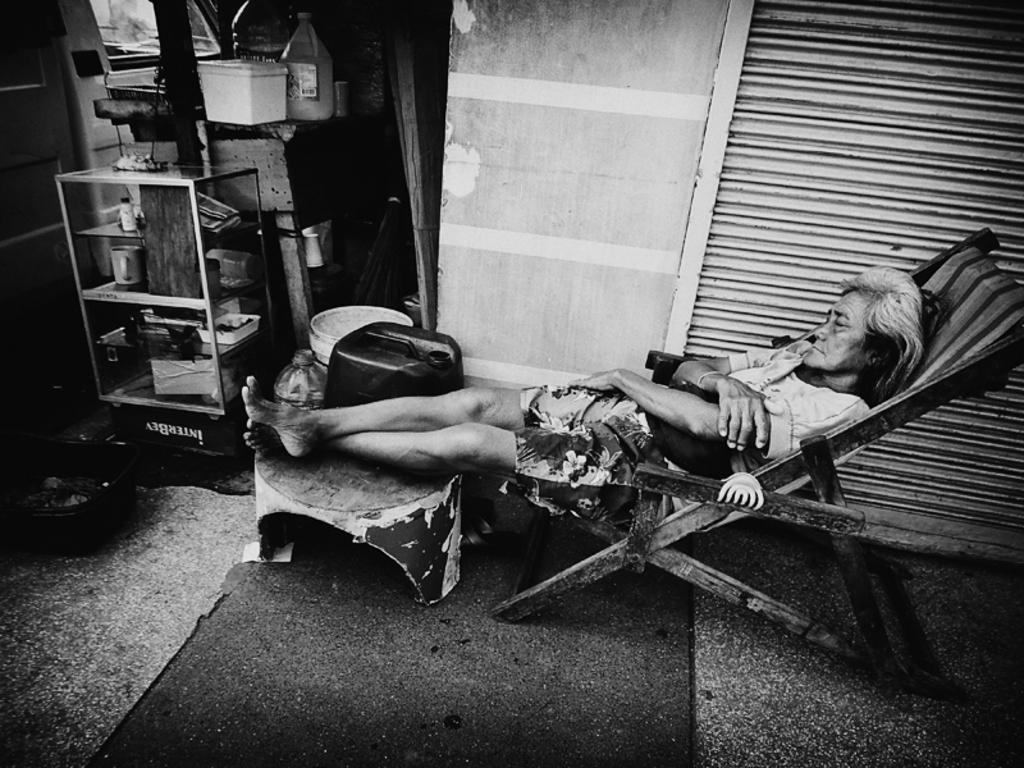Describe this image in one or two sentences. In this image I can see one person lying on the chair. To the side of the person I can see the wall. To the left there is a glass rack and some objects in it. In the back I can see a bottle, box and few more objects on the table. And this is a black and white image. 